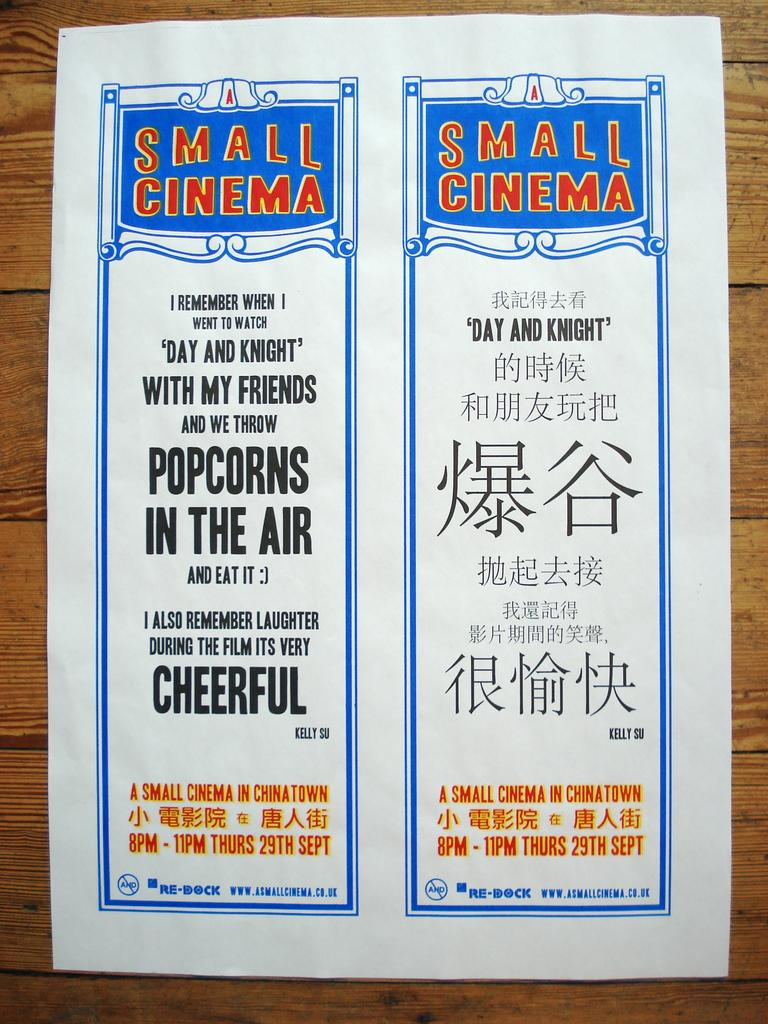<image>
Give a short and clear explanation of the subsequent image. a sign ad written in english and chinese 